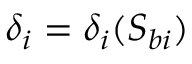Convert formula to latex. <formula><loc_0><loc_0><loc_500><loc_500>\delta _ { i } = \delta _ { i } ( S _ { b i } )</formula> 